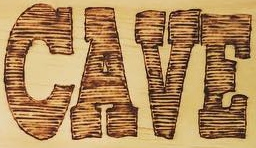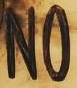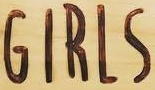What words can you see in these images in sequence, separated by a semicolon? CAVE; NO; GIRLS 